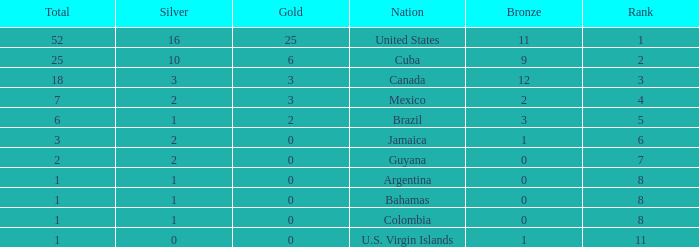What is the fewest number of silver medals a nation who ranked below 8 received? 0.0. 